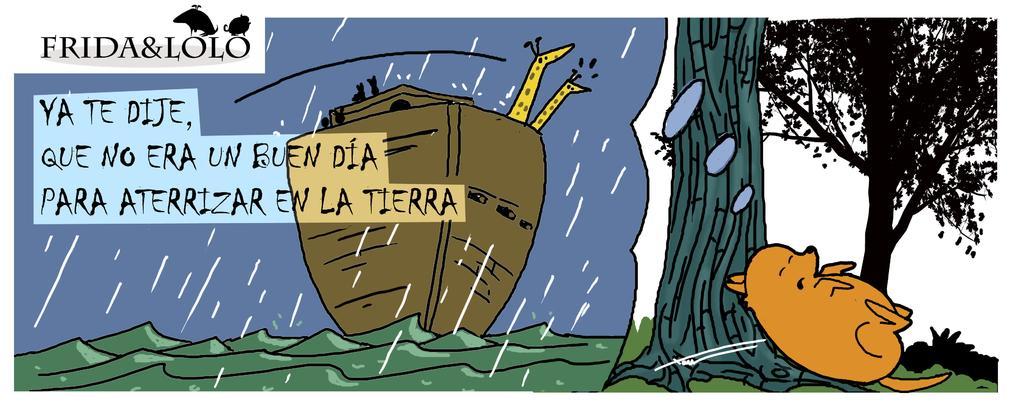In one or two sentences, can you explain what this image depicts? This image is a cartoon. In the center of the image we can see a ship on the water. On the right there is an animal sleeping and there are trees. We can see text. At the bottom there is grass. 